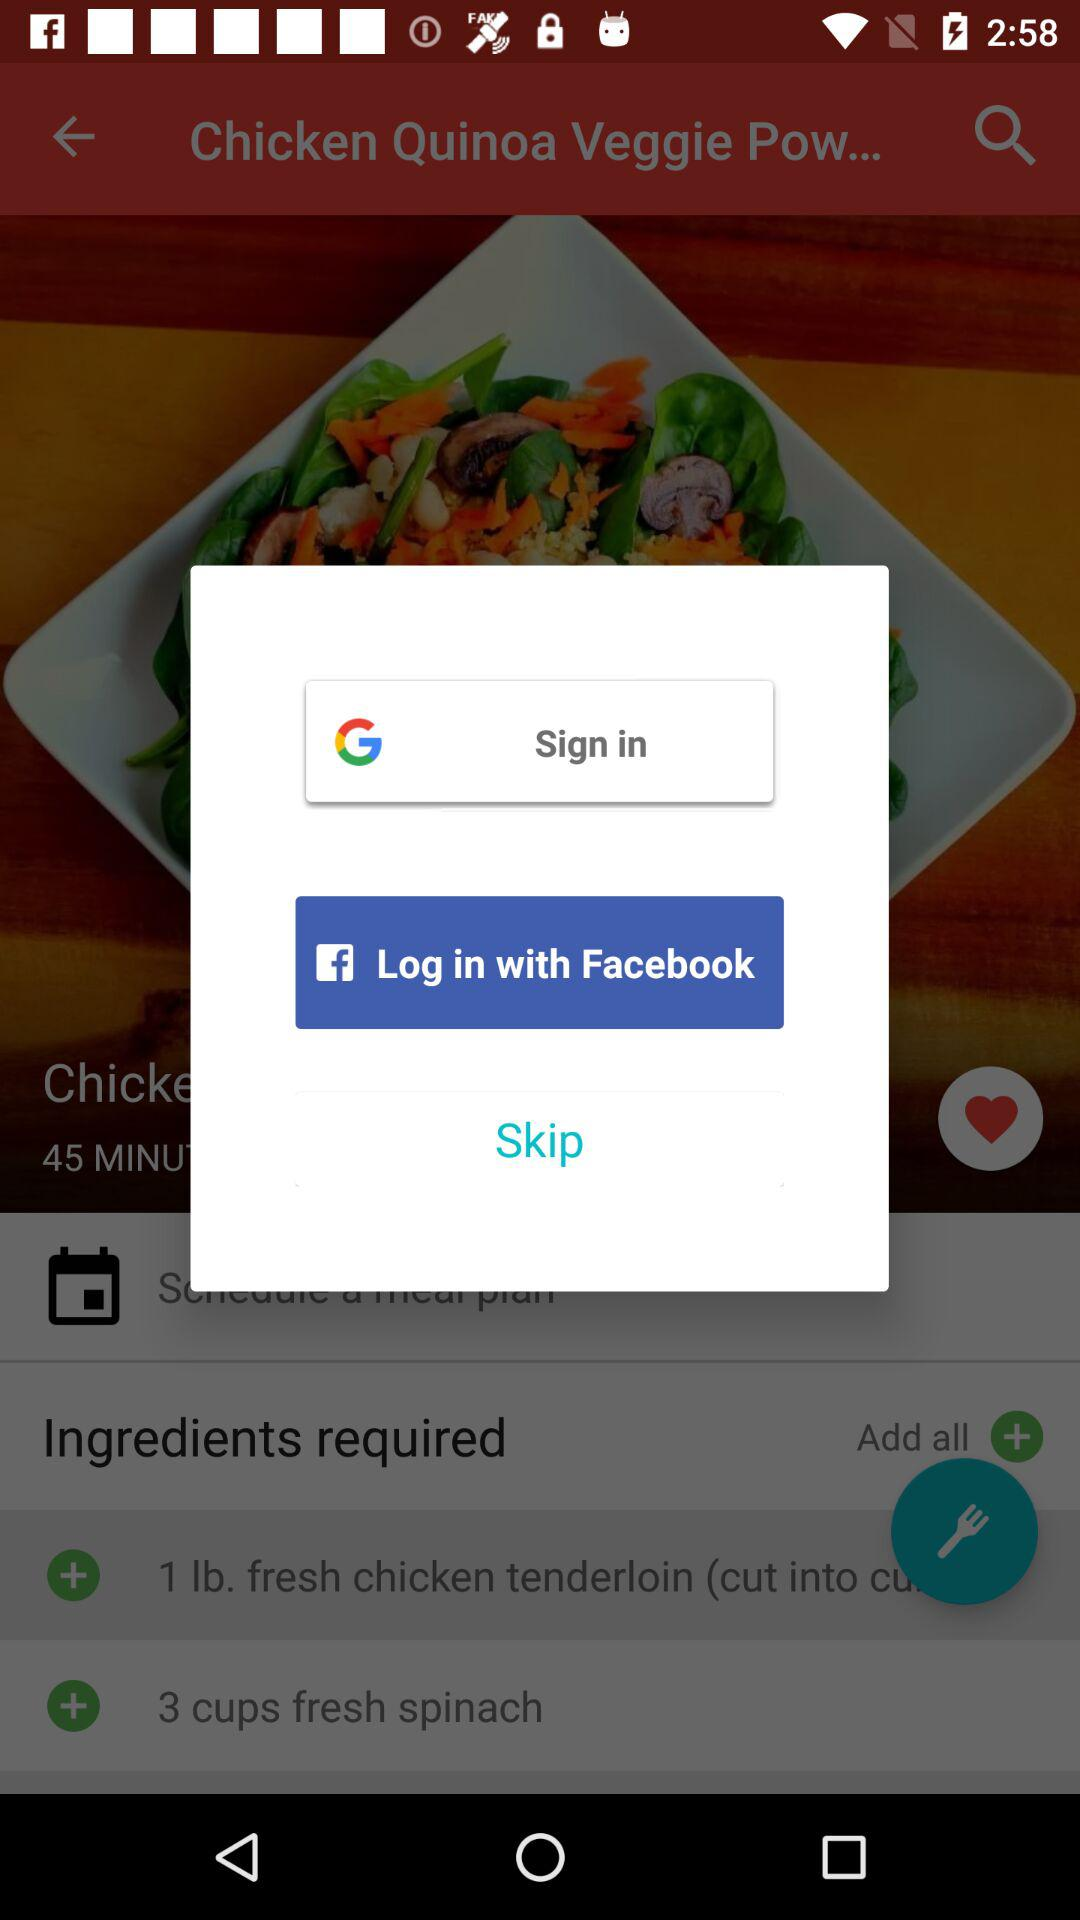What is the different login option? The different login options are "Google" and "Facebook". 